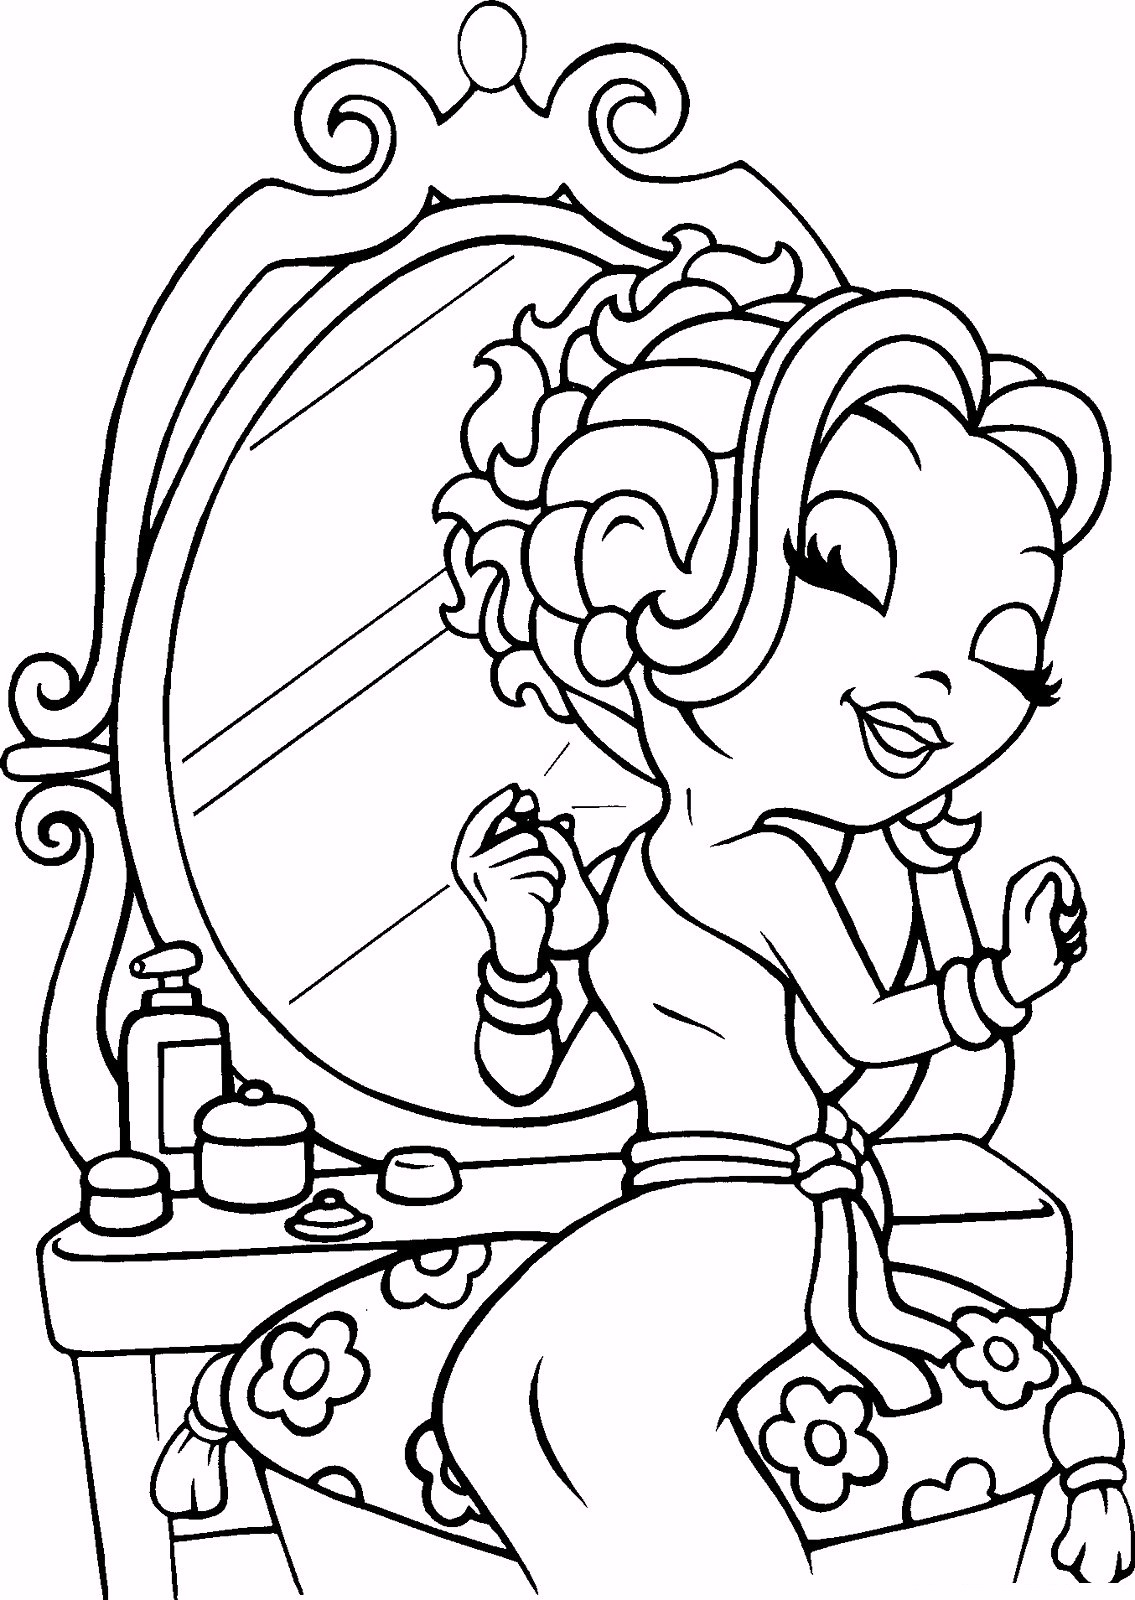What other personal care routines could the girl be about to engage in with the products visible on the table? Apart from painting her nails, the girl might use the other products on the table for a variety of personal care routines. The pump bottle could contain lotion, suggesting she might be moisturizing her hands or body. The small jars could hold face creams, indicating a skincare routine. Additionally, she might be engaged in makeup application, given the mirror and the overall beauty context of the setting. 